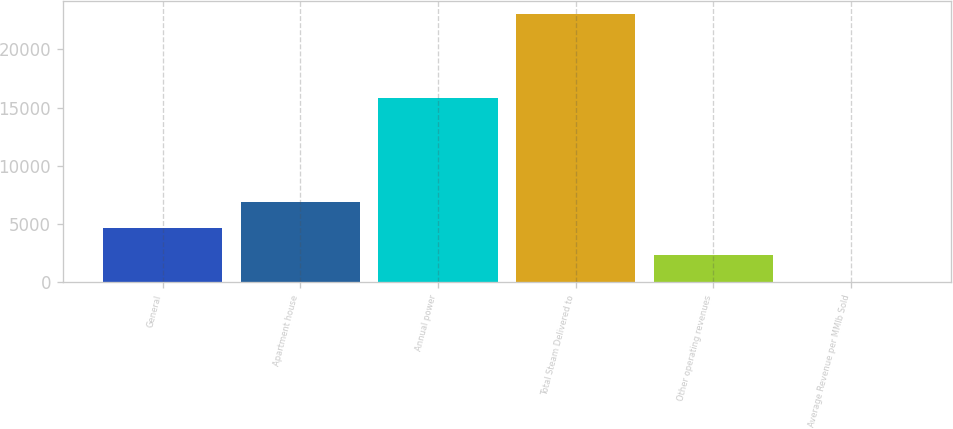Convert chart to OTSL. <chart><loc_0><loc_0><loc_500><loc_500><bar_chart><fcel>General<fcel>Apartment house<fcel>Annual power<fcel>Total Steam Delivered to<fcel>Other operating revenues<fcel>Average Revenue per MMlb Sold<nl><fcel>4626.8<fcel>6925.45<fcel>15848<fcel>23016<fcel>2328.15<fcel>29.5<nl></chart> 